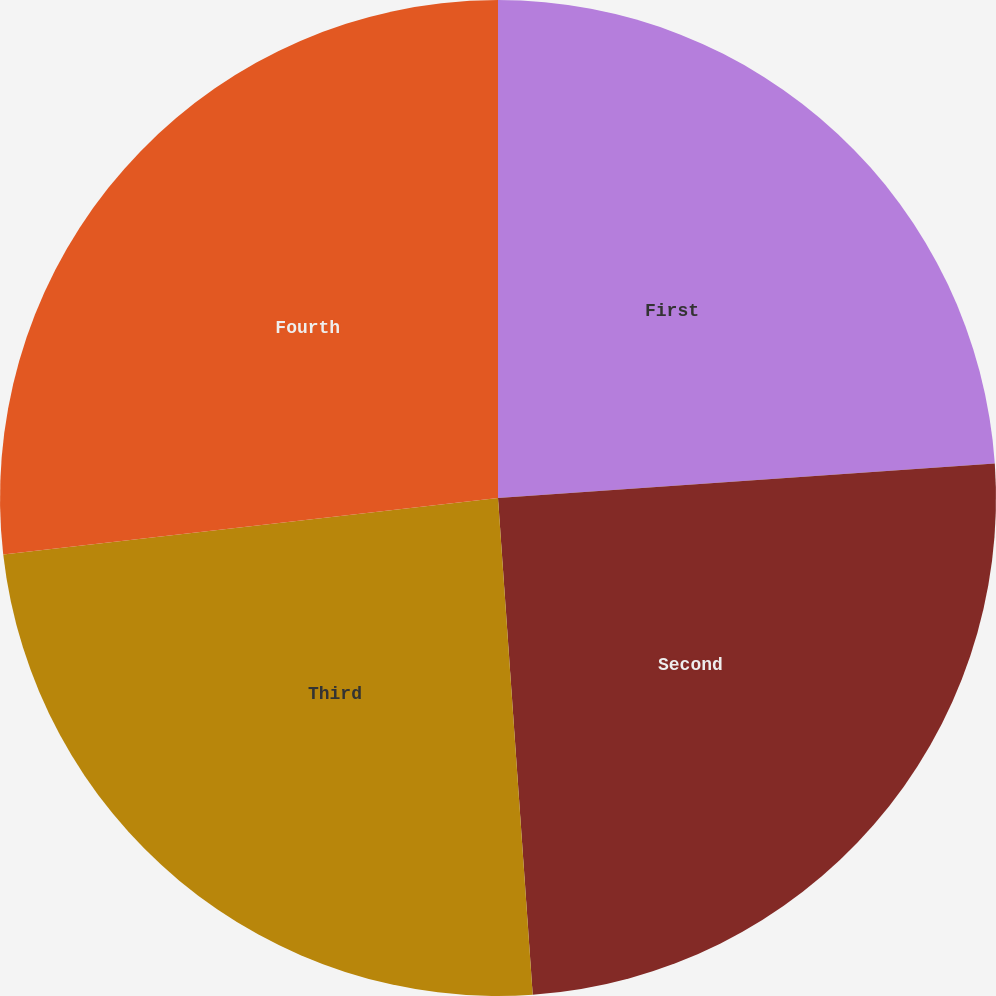Convert chart. <chart><loc_0><loc_0><loc_500><loc_500><pie_chart><fcel>First<fcel>Second<fcel>Third<fcel>Fourth<nl><fcel>23.9%<fcel>24.99%<fcel>24.3%<fcel>26.81%<nl></chart> 